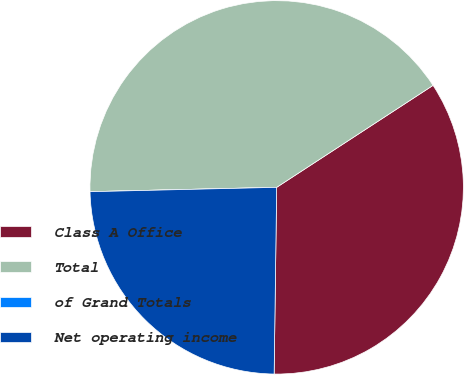Convert chart. <chart><loc_0><loc_0><loc_500><loc_500><pie_chart><fcel>Class A Office<fcel>Total<fcel>of Grand Totals<fcel>Net operating income<nl><fcel>34.41%<fcel>41.17%<fcel>0.0%<fcel>24.41%<nl></chart> 